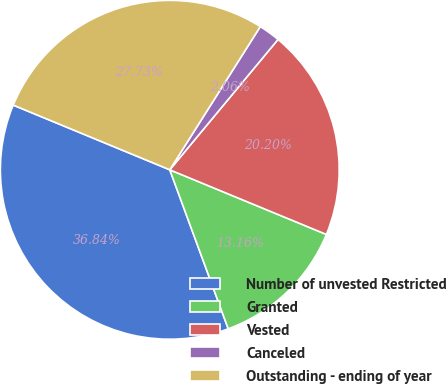<chart> <loc_0><loc_0><loc_500><loc_500><pie_chart><fcel>Number of unvested Restricted<fcel>Granted<fcel>Vested<fcel>Canceled<fcel>Outstanding - ending of year<nl><fcel>36.84%<fcel>13.16%<fcel>20.2%<fcel>2.06%<fcel>27.73%<nl></chart> 